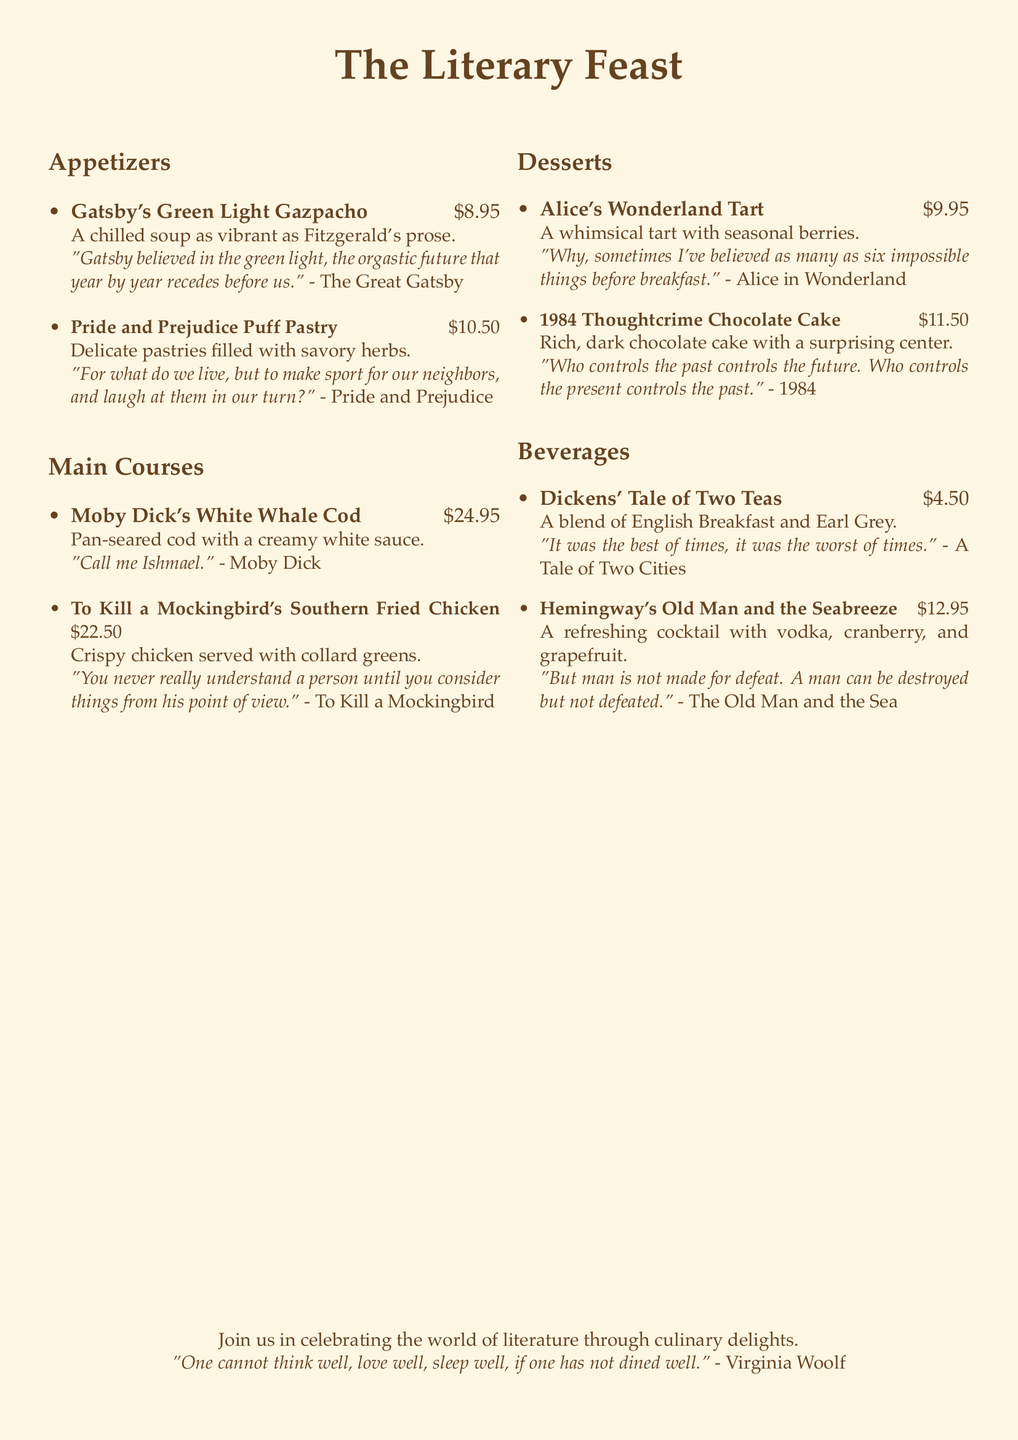What is the price of Gatsby's Green Light Gazpacho? The price is listed next to the dish, which is $8.95.
Answer: $8.95 What dish is inspired by Moby Dick? The dish inspired by Moby Dick is named Moby Dick's White Whale Cod.
Answer: Moby Dick's White Whale Cod Which dessert features seasonal berries? The dessert with seasonal berries is Alice's Wonderland Tart.
Answer: Alice's Wonderland Tart What quote is associated with To Kill a Mockingbird's Southern Fried Chicken? The quote is referenced in the description of the dish and states, "You never really understand a person until you consider things from his point of view."
Answer: "You never really understand a person until you consider things from his point of view." How much does Hemingway's Old Man and the Seabreeze cost? The cost is mentioned alongside the dish, which is $12.95.
Answer: $12.95 What are the two teas in Dickens' Tale of Two Teas? The teas included in the blend are English Breakfast and Earl Grey.
Answer: English Breakfast and Earl Grey What type of cuisine is featured in the main courses? The main courses showcase a variety of culinary styles influenced by classic literature.
Answer: A variety of culinary styles How many appetizers are listed on the menu? The menu indicates a total of two appetizers under the Appetizers section.
Answer: Two Which book's quote is referenced for the dessert 1984 Thoughtcrime Chocolate Cake? The quote is from the book 1984.
Answer: 1984 